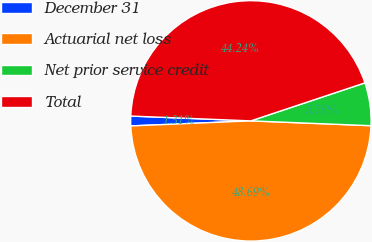Convert chart to OTSL. <chart><loc_0><loc_0><loc_500><loc_500><pie_chart><fcel>December 31<fcel>Actuarial net loss<fcel>Net prior service credit<fcel>Total<nl><fcel>1.31%<fcel>48.69%<fcel>5.76%<fcel>44.24%<nl></chart> 